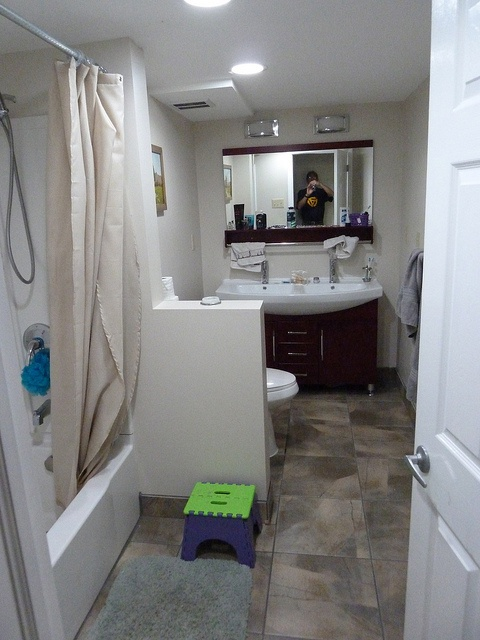Describe the objects in this image and their specific colors. I can see sink in gray, darkgray, and lightgray tones, people in gray and black tones, and toilet in gray, darkgray, lightgray, and black tones in this image. 